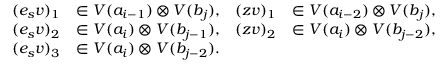<formula> <loc_0><loc_0><loc_500><loc_500>\begin{array} { r l r l } { ( e _ { s } v ) _ { 1 } } & { \in V ( a _ { i - 1 } ) \otimes V ( b _ { j } ) , } & { ( z v ) _ { 1 } } & { \in V ( a _ { i - 2 } ) \otimes V ( b _ { j } ) , } \\ { ( e _ { s } v ) _ { 2 } } & { \in V ( a _ { i } ) \otimes V ( b _ { j - 1 } ) , } & { ( z v ) _ { 2 } } & { \in V ( a _ { i } ) \otimes V ( b _ { j - 2 } ) , } \\ { ( e _ { s } v ) _ { 3 } } & { \in V ( a _ { i } ) \otimes V ( b _ { j - 2 } ) . } & \end{array}</formula> 